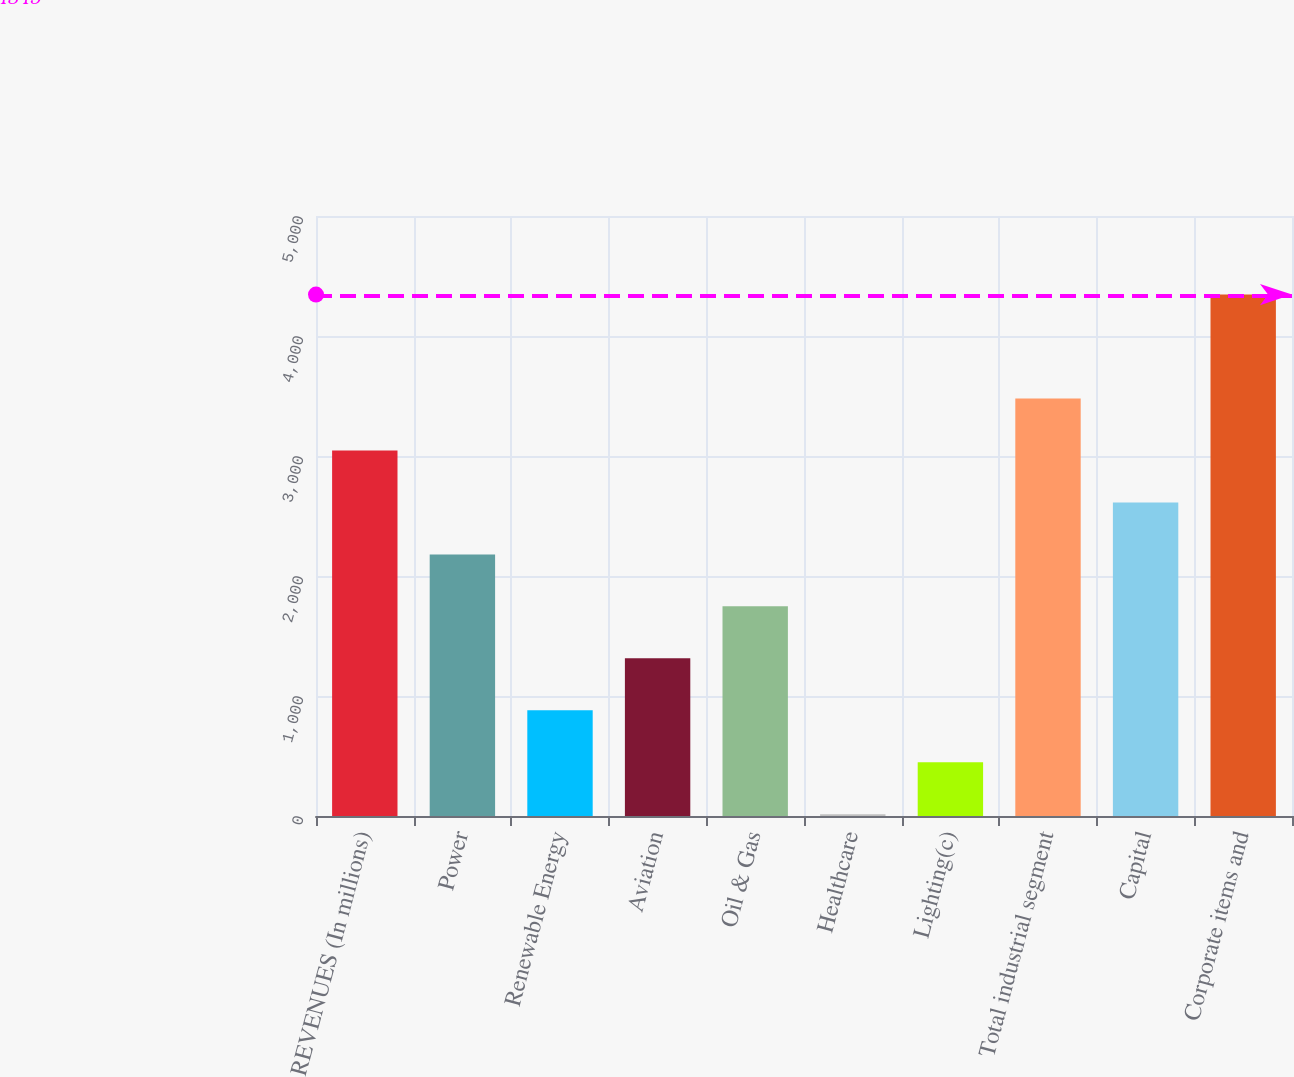Convert chart. <chart><loc_0><loc_0><loc_500><loc_500><bar_chart><fcel>REVENUES (In millions)<fcel>Power<fcel>Renewable Energy<fcel>Aviation<fcel>Oil & Gas<fcel>Healthcare<fcel>Lighting(c)<fcel>Total industrial segment<fcel>Capital<fcel>Corporate items and<nl><fcel>3046<fcel>2180<fcel>881<fcel>1314<fcel>1747<fcel>15<fcel>448<fcel>3479<fcel>2613<fcel>4345<nl></chart> 